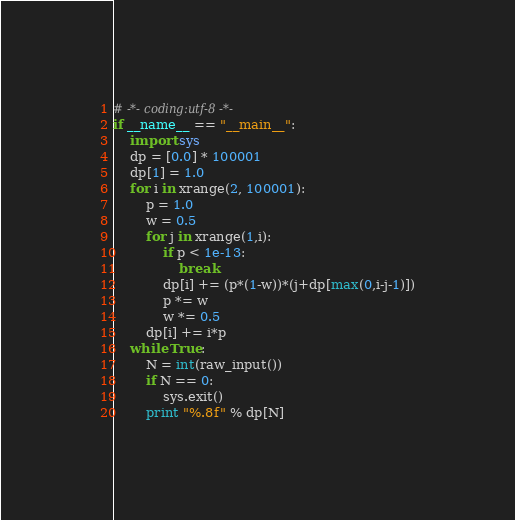<code> <loc_0><loc_0><loc_500><loc_500><_Python_># -*- coding:utf-8 -*-
if __name__ == "__main__":
    import sys
    dp = [0.0] * 100001
    dp[1] = 1.0
    for i in xrange(2, 100001):
        p = 1.0
        w = 0.5
        for j in xrange(1,i):
            if p < 1e-13:
                break
            dp[i] += (p*(1-w))*(j+dp[max(0,i-j-1)])
            p *= w
            w *= 0.5
        dp[i] += i*p
    while True:
        N = int(raw_input())
        if N == 0:
            sys.exit()
        print "%.8f" % dp[N]</code> 